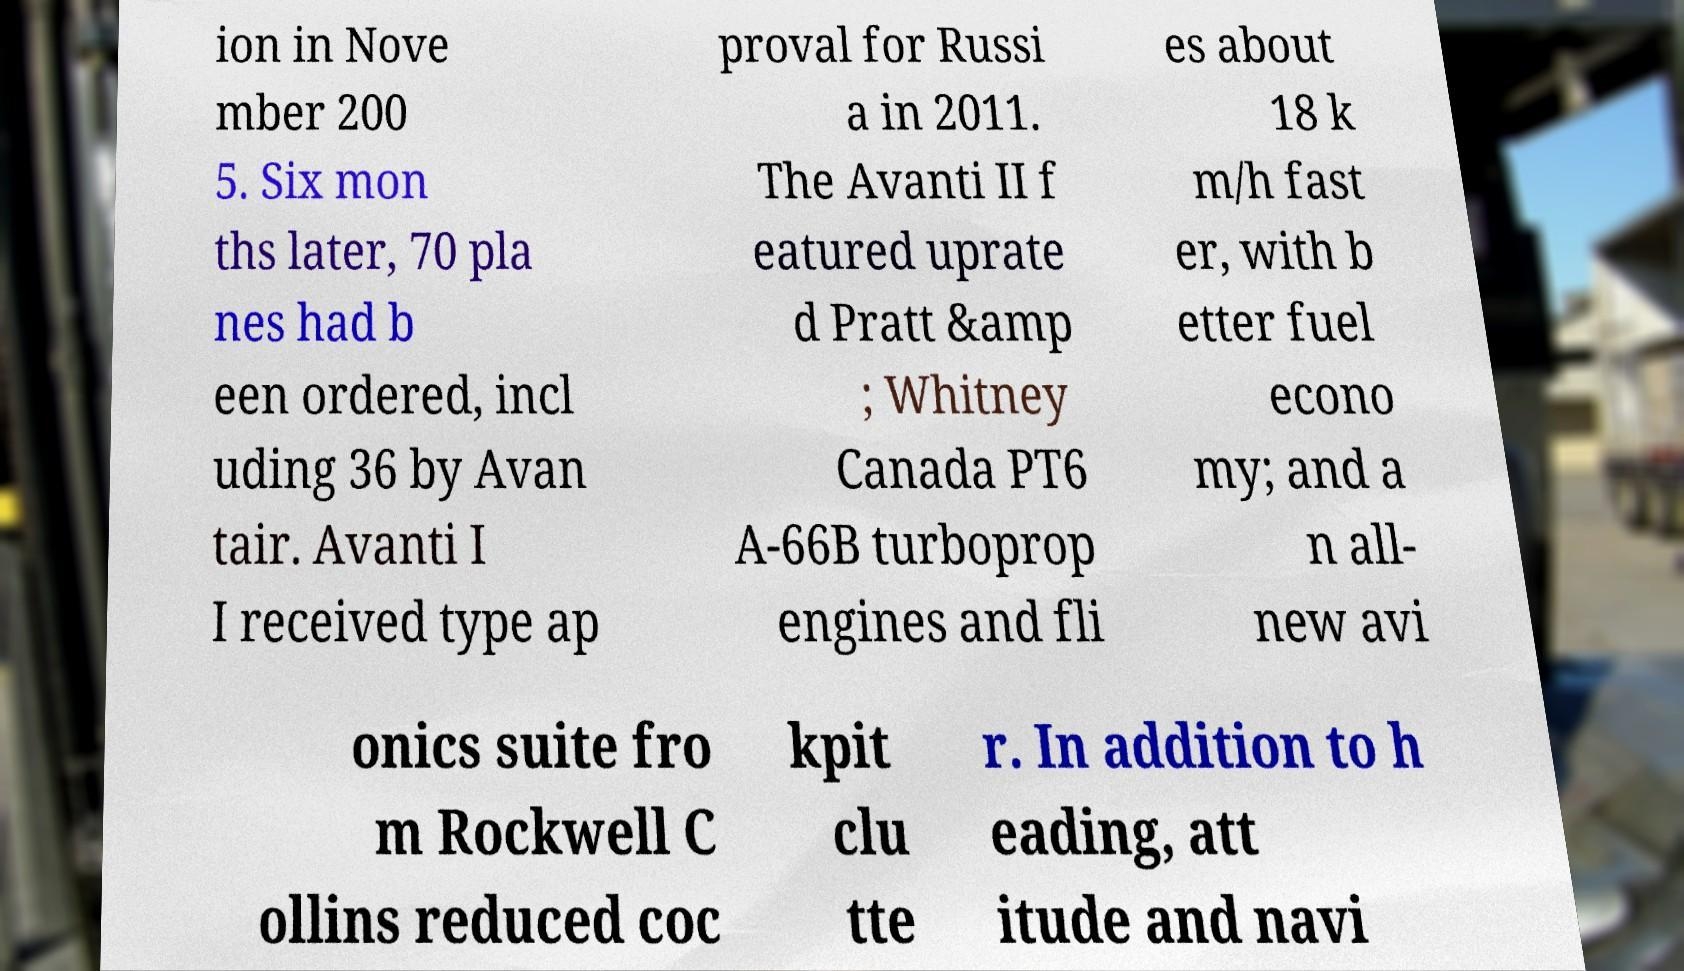Could you extract and type out the text from this image? ion in Nove mber 200 5. Six mon ths later, 70 pla nes had b een ordered, incl uding 36 by Avan tair. Avanti I I received type ap proval for Russi a in 2011. The Avanti II f eatured uprate d Pratt &amp ; Whitney Canada PT6 A-66B turboprop engines and fli es about 18 k m/h fast er, with b etter fuel econo my; and a n all- new avi onics suite fro m Rockwell C ollins reduced coc kpit clu tte r. In addition to h eading, att itude and navi 